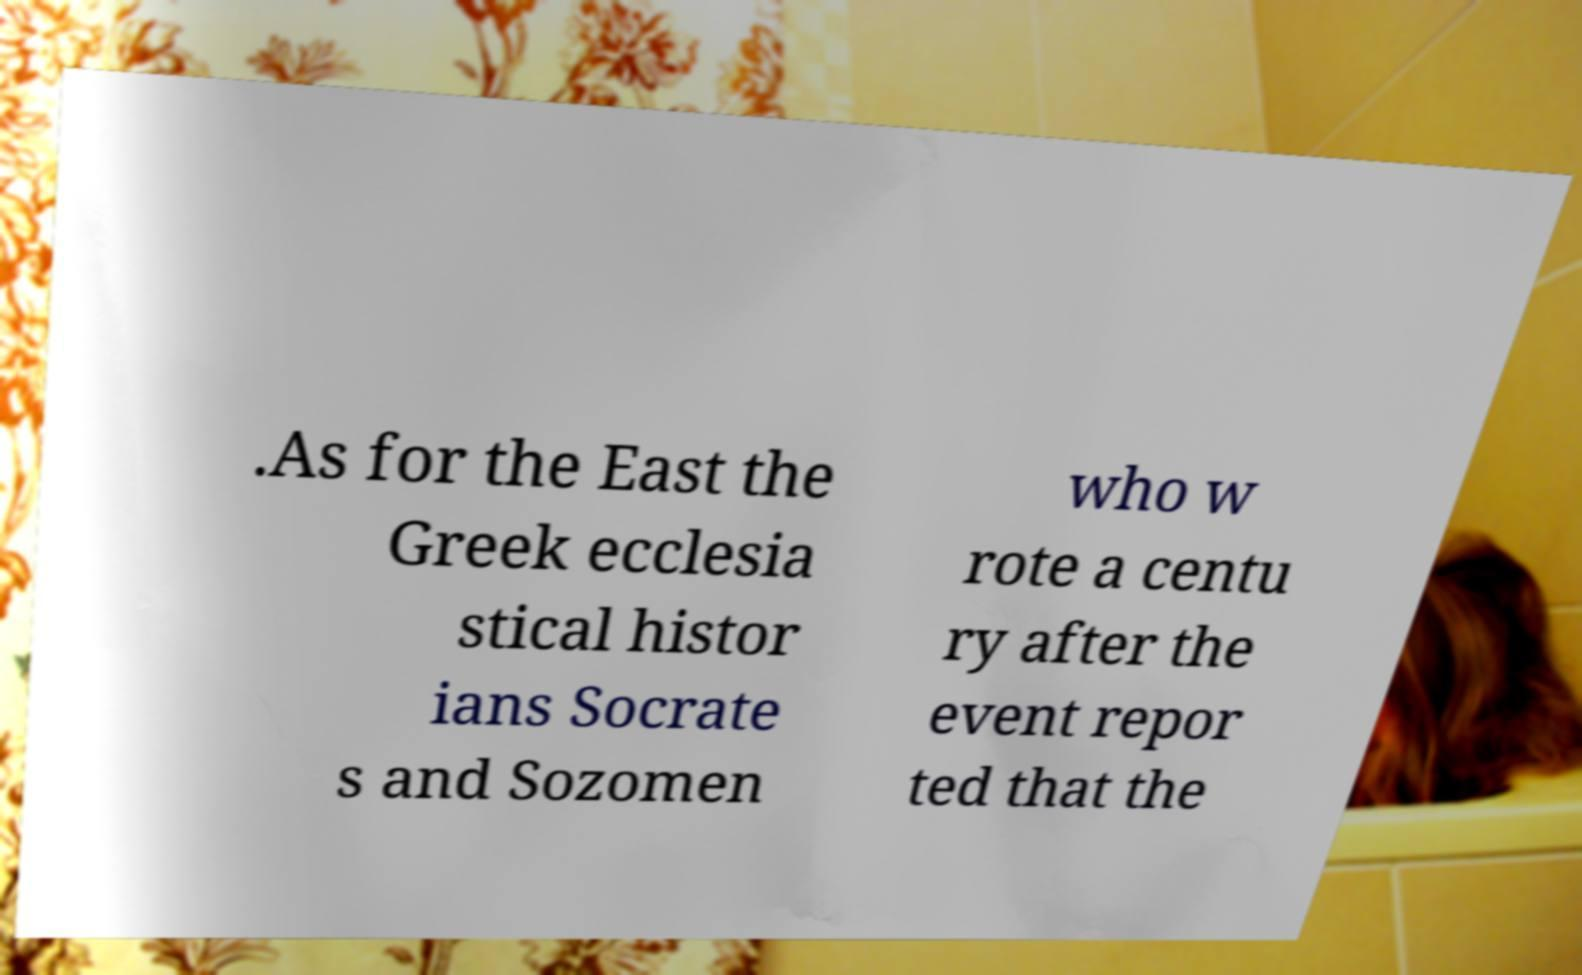Please identify and transcribe the text found in this image. .As for the East the Greek ecclesia stical histor ians Socrate s and Sozomen who w rote a centu ry after the event repor ted that the 